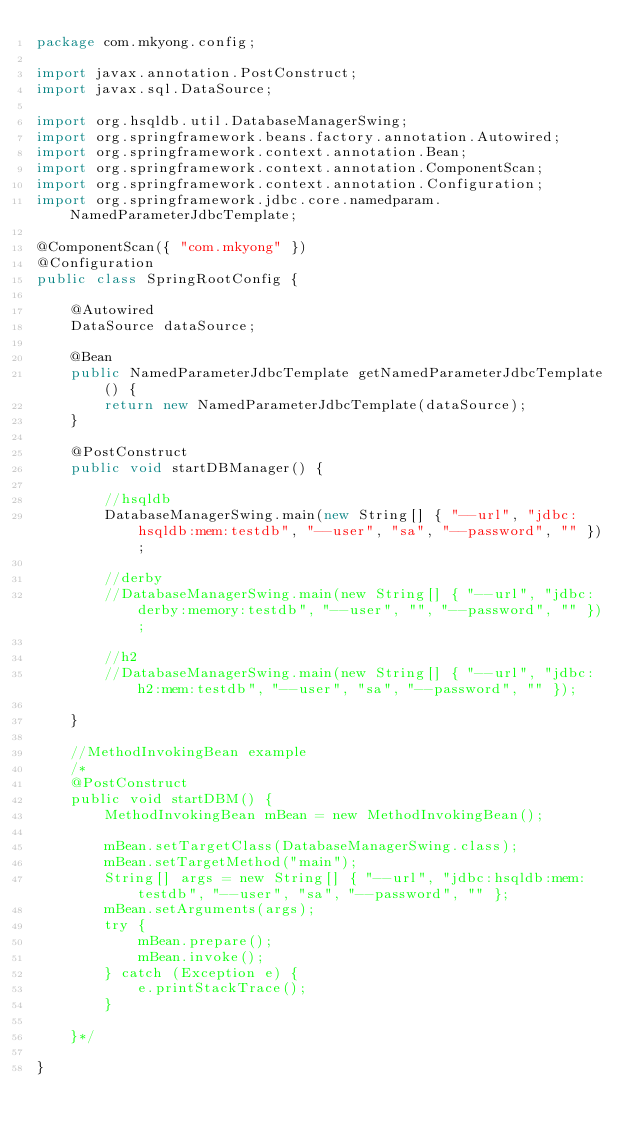<code> <loc_0><loc_0><loc_500><loc_500><_Java_>package com.mkyong.config;

import javax.annotation.PostConstruct;
import javax.sql.DataSource;

import org.hsqldb.util.DatabaseManagerSwing;
import org.springframework.beans.factory.annotation.Autowired;
import org.springframework.context.annotation.Bean;
import org.springframework.context.annotation.ComponentScan;
import org.springframework.context.annotation.Configuration;
import org.springframework.jdbc.core.namedparam.NamedParameterJdbcTemplate;

@ComponentScan({ "com.mkyong" })
@Configuration
public class SpringRootConfig {

	@Autowired
	DataSource dataSource;

	@Bean
	public NamedParameterJdbcTemplate getNamedParameterJdbcTemplate() {
		return new NamedParameterJdbcTemplate(dataSource);
	}
	
	@PostConstruct
	public void startDBManager() {
		
		//hsqldb
		DatabaseManagerSwing.main(new String[] { "--url", "jdbc:hsqldb:mem:testdb", "--user", "sa", "--password", "" });

		//derby
		//DatabaseManagerSwing.main(new String[] { "--url", "jdbc:derby:memory:testdb", "--user", "", "--password", "" });

		//h2
		//DatabaseManagerSwing.main(new String[] { "--url", "jdbc:h2:mem:testdb", "--user", "sa", "--password", "" });

	}
	
	//MethodInvokingBean example
	/*
	@PostConstruct
	public void startDBM() {
		MethodInvokingBean mBean = new MethodInvokingBean();

		mBean.setTargetClass(DatabaseManagerSwing.class);
		mBean.setTargetMethod("main");
		String[] args = new String[] { "--url", "jdbc:hsqldb:mem:testdb", "--user", "sa", "--password", "" };
		mBean.setArguments(args);
		try {
			mBean.prepare();
			mBean.invoke();
		} catch (Exception e) {
			e.printStackTrace();
		}
		
	}*/

}</code> 